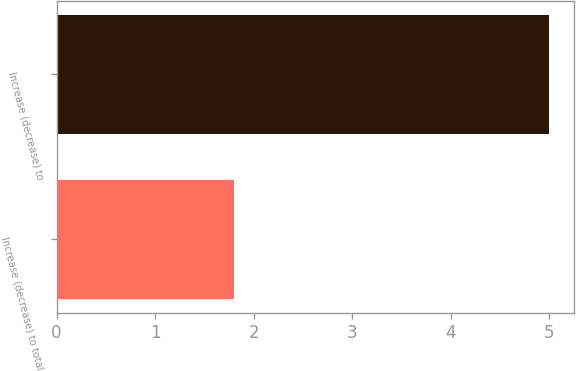Convert chart. <chart><loc_0><loc_0><loc_500><loc_500><bar_chart><fcel>Increase (decrease) to total<fcel>Increase (decrease) to<nl><fcel>1.8<fcel>5<nl></chart> 